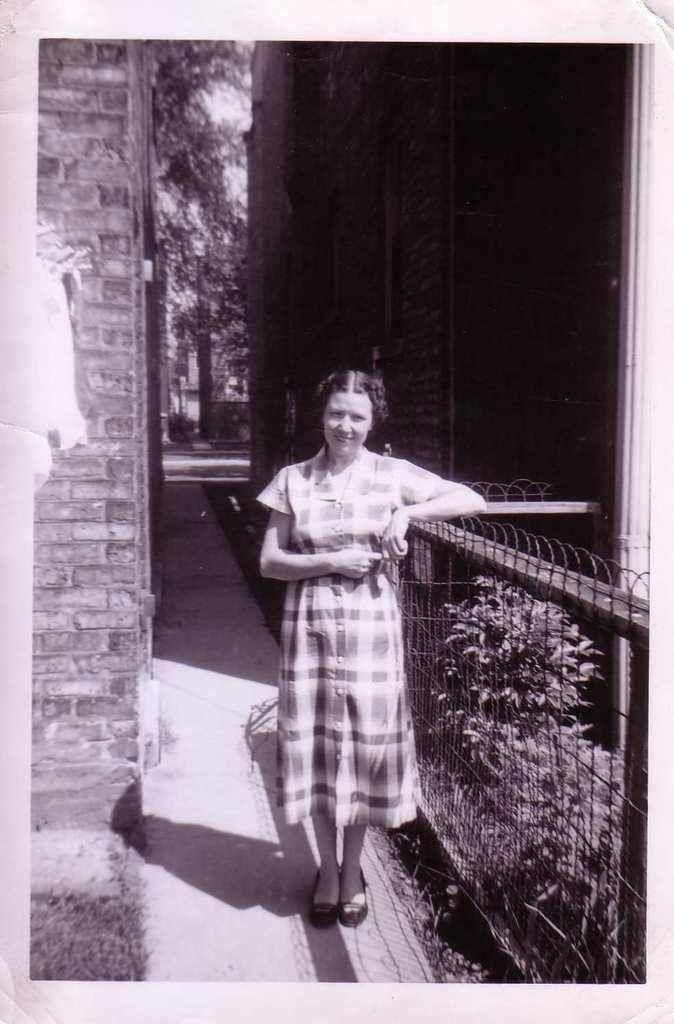In one or two sentences, can you explain what this image depicts? In the foreground I can see a woman is standing on the road near the fence and plants. In the background I can see buildings, door and trees. This image is taken may be during a day. 